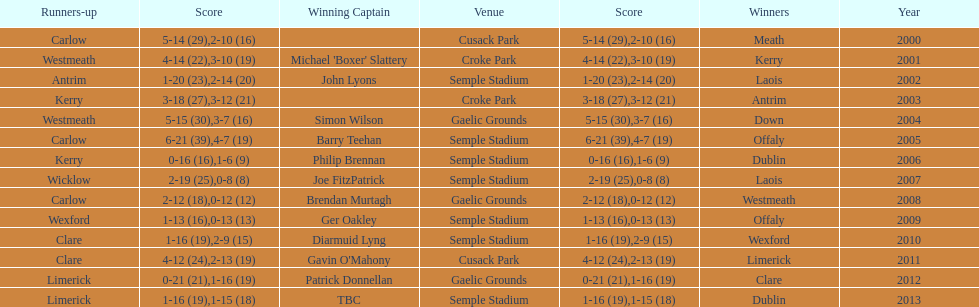Which team was the first to win with a team captain? Kerry. 